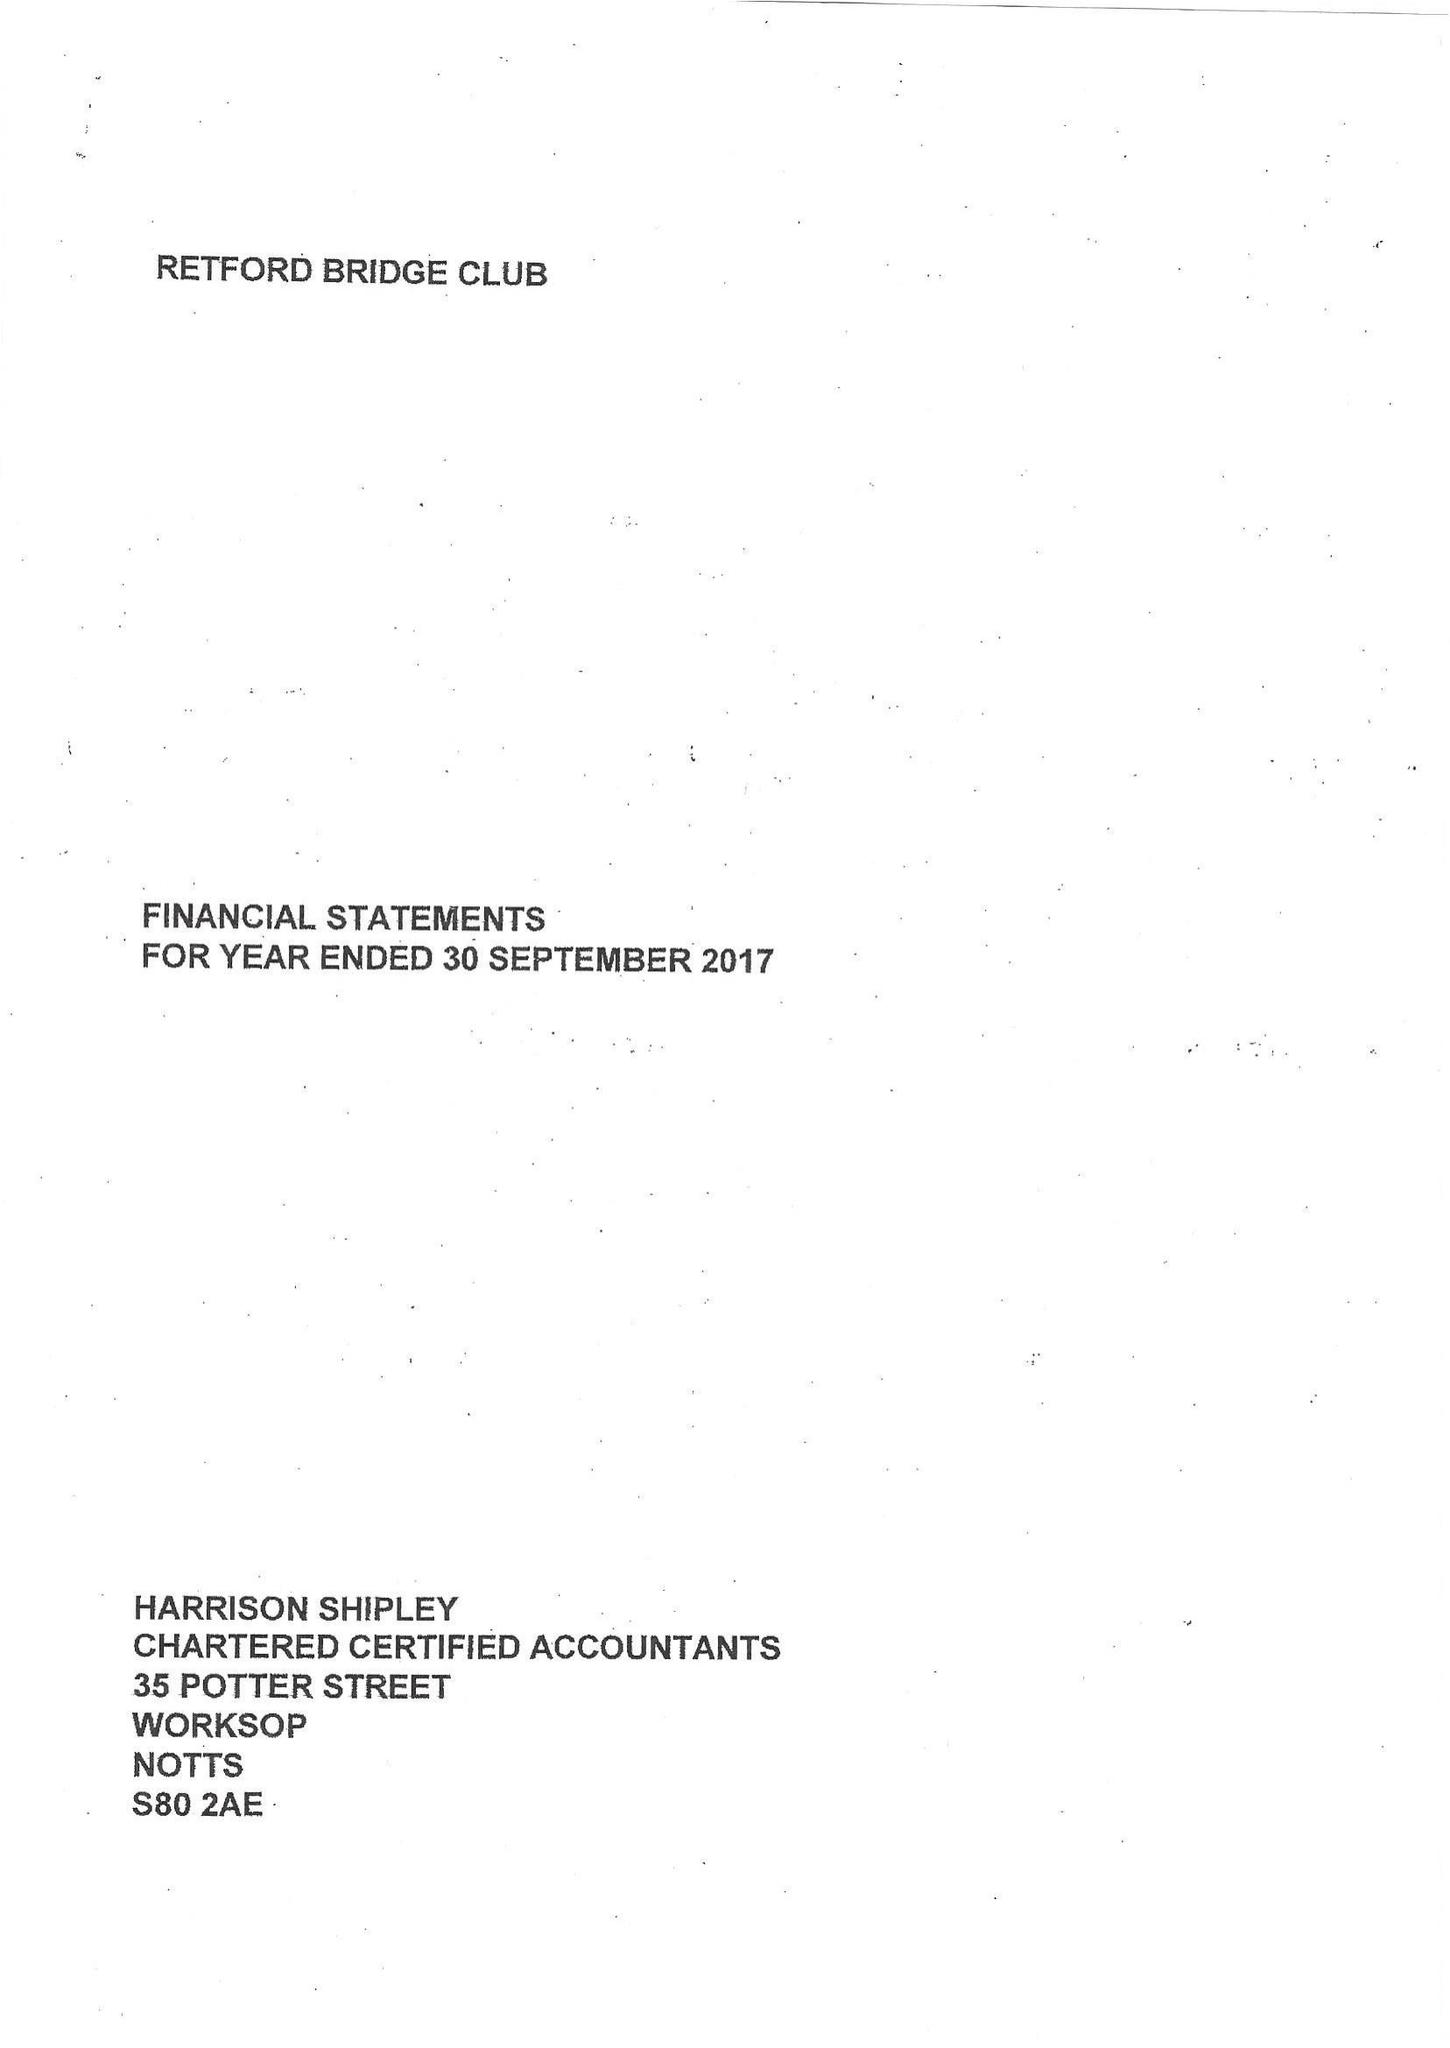What is the value for the report_date?
Answer the question using a single word or phrase. 2017-09-30 